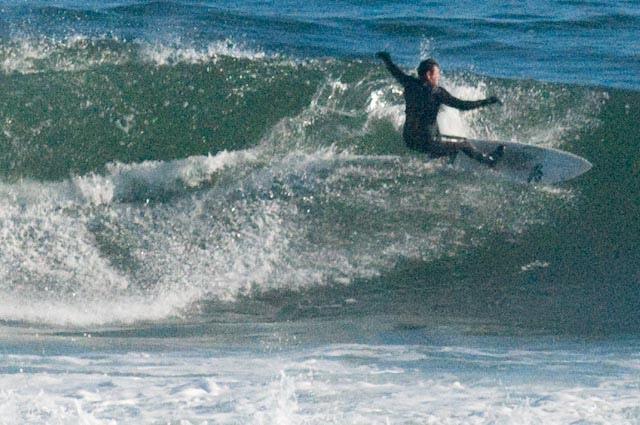Is the surfer in a wetsuit?
Answer briefly. Yes. Is this surfer wearing a wetsuit?
Write a very short answer. Yes. Is the water calm?
Concise answer only. No. What direction is the surfboard pointing?
Be succinct. Right. Is the man going to fall?
Keep it brief. Yes. 